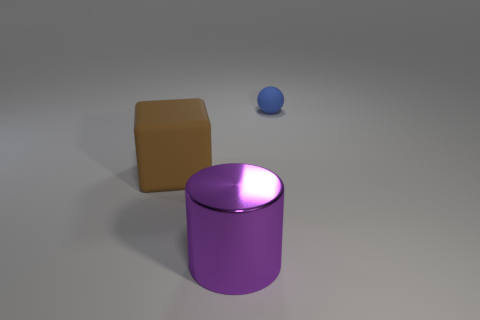What color is the thing behind the large brown matte block?
Your response must be concise. Blue. What shape is the big purple object?
Make the answer very short. Cylinder. What is the material of the large cube behind the metallic object in front of the brown rubber thing?
Your answer should be very brief. Rubber. What number of other things are the same material as the block?
Your answer should be compact. 1. There is a purple thing that is the same size as the block; what is it made of?
Keep it short and to the point. Metal. Are there more large metallic cylinders in front of the big brown object than rubber cubes that are in front of the big metallic object?
Make the answer very short. Yes. Are there any red objects that have the same shape as the brown matte thing?
Provide a short and direct response. No. What shape is the other object that is the same size as the purple object?
Your response must be concise. Cube. There is a thing left of the big purple thing; what is its shape?
Make the answer very short. Cube. Is the number of small blue things that are in front of the ball less than the number of big brown blocks that are in front of the large purple cylinder?
Give a very brief answer. No. 